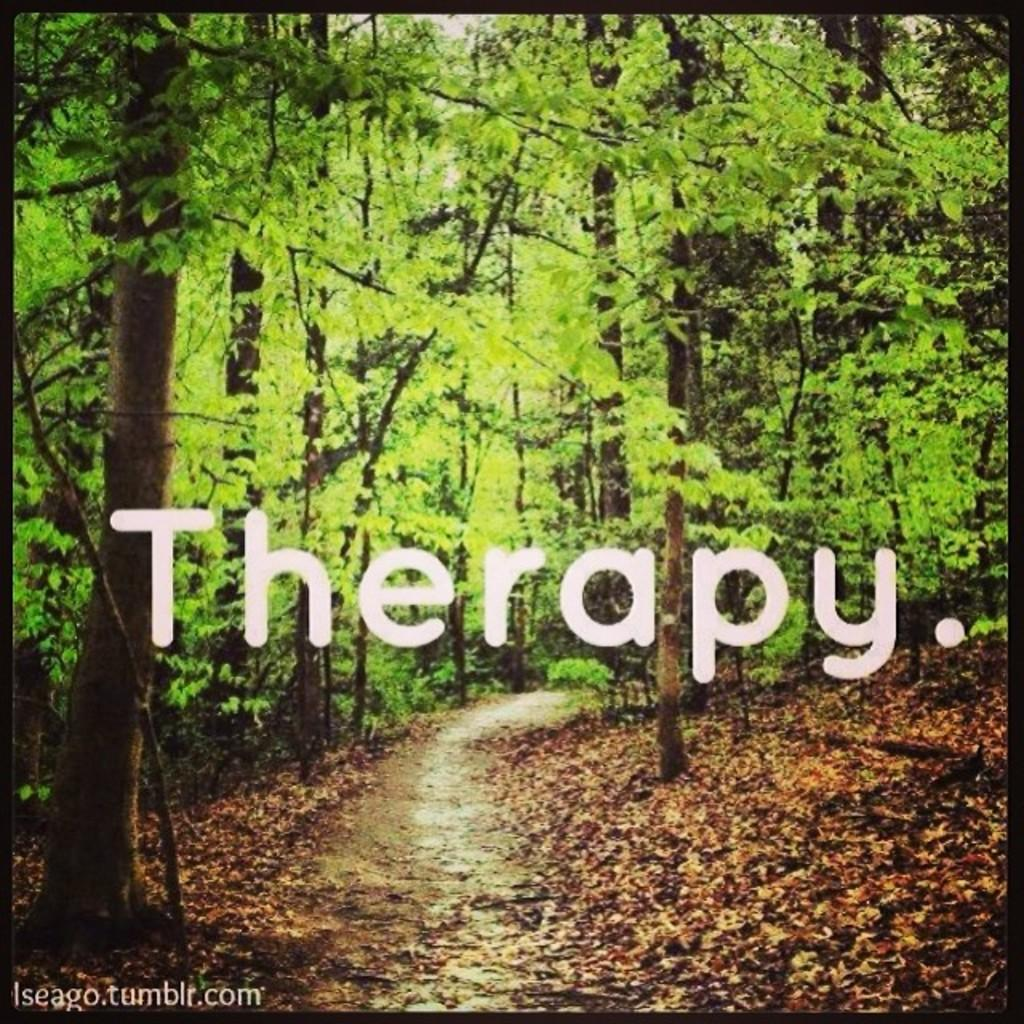What type of vegetation can be seen in the image? There are trees in the image. What can be found between the trees? There is a path in the image. What is on the ground beneath the trees? Leaves are present on the ground in the image. Are there any visible imperfections on the image? Yes, there are watermarks on the image. What type of straw is used to decorate the trees in the image? There is no straw present in the image; it features trees, a path, leaves on the ground, and watermarks. 